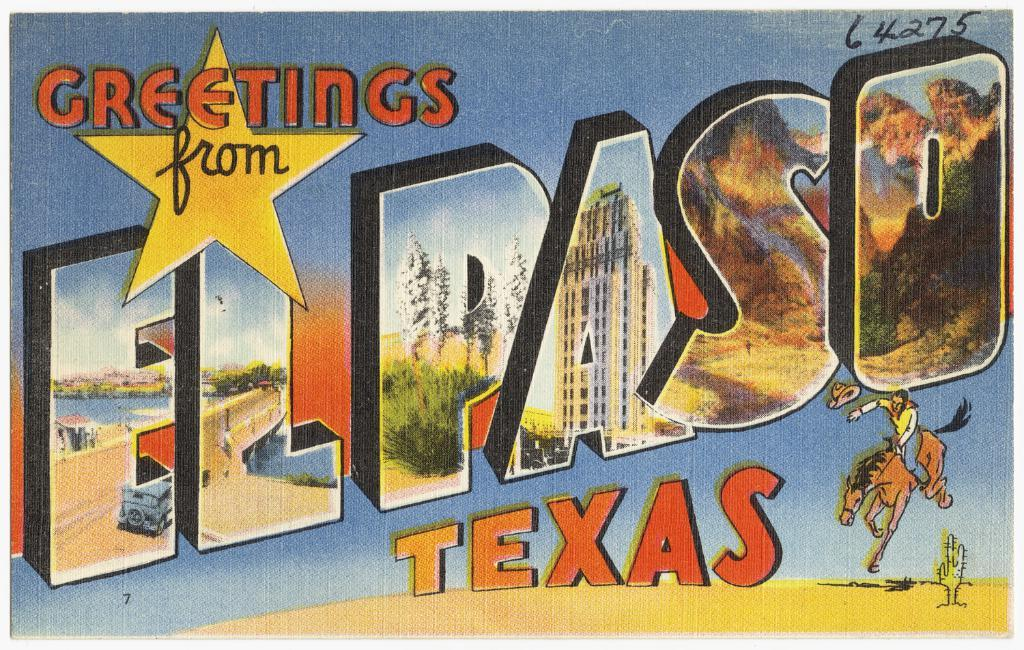Provide a one-sentence caption for the provided image. A picture of a post card from El Paso Texas. 